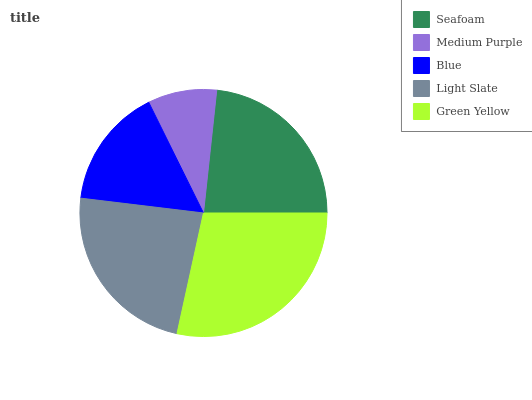Is Medium Purple the minimum?
Answer yes or no. Yes. Is Green Yellow the maximum?
Answer yes or no. Yes. Is Blue the minimum?
Answer yes or no. No. Is Blue the maximum?
Answer yes or no. No. Is Blue greater than Medium Purple?
Answer yes or no. Yes. Is Medium Purple less than Blue?
Answer yes or no. Yes. Is Medium Purple greater than Blue?
Answer yes or no. No. Is Blue less than Medium Purple?
Answer yes or no. No. Is Seafoam the high median?
Answer yes or no. Yes. Is Seafoam the low median?
Answer yes or no. Yes. Is Medium Purple the high median?
Answer yes or no. No. Is Light Slate the low median?
Answer yes or no. No. 